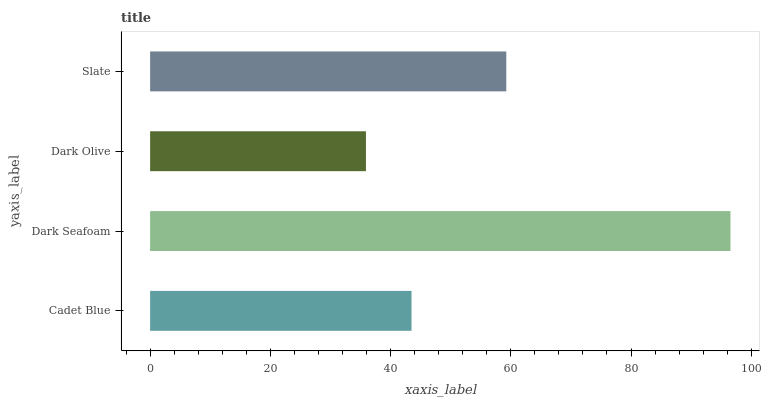Is Dark Olive the minimum?
Answer yes or no. Yes. Is Dark Seafoam the maximum?
Answer yes or no. Yes. Is Dark Seafoam the minimum?
Answer yes or no. No. Is Dark Olive the maximum?
Answer yes or no. No. Is Dark Seafoam greater than Dark Olive?
Answer yes or no. Yes. Is Dark Olive less than Dark Seafoam?
Answer yes or no. Yes. Is Dark Olive greater than Dark Seafoam?
Answer yes or no. No. Is Dark Seafoam less than Dark Olive?
Answer yes or no. No. Is Slate the high median?
Answer yes or no. Yes. Is Cadet Blue the low median?
Answer yes or no. Yes. Is Dark Seafoam the high median?
Answer yes or no. No. Is Dark Olive the low median?
Answer yes or no. No. 